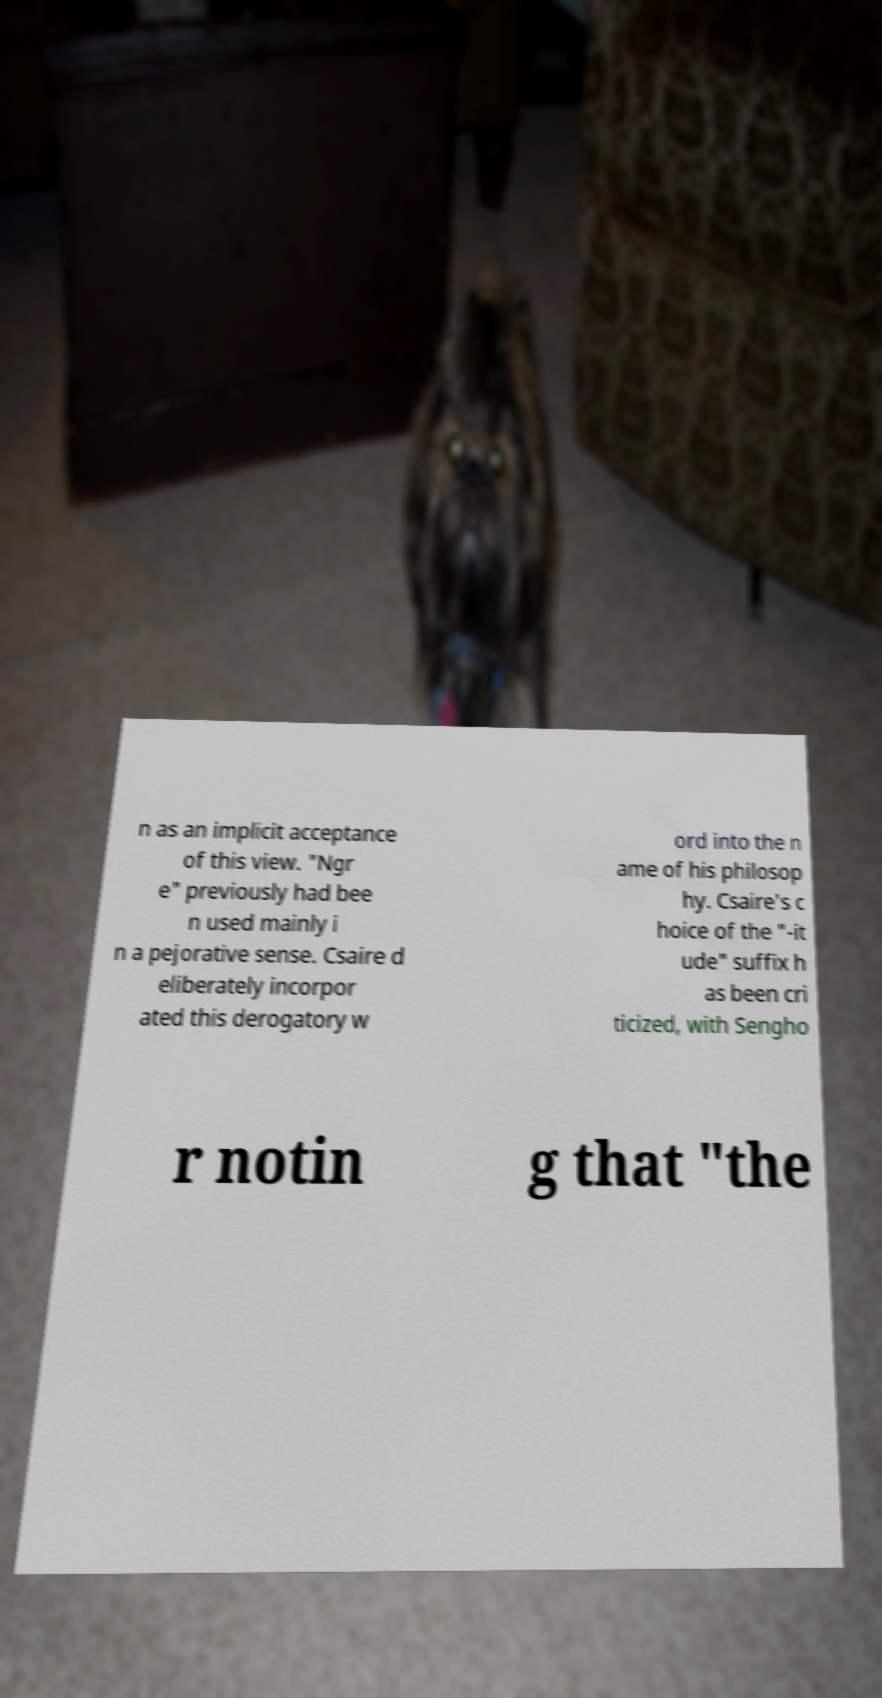I need the written content from this picture converted into text. Can you do that? n as an implicit acceptance of this view. "Ngr e" previously had bee n used mainly i n a pejorative sense. Csaire d eliberately incorpor ated this derogatory w ord into the n ame of his philosop hy. Csaire's c hoice of the "-it ude" suffix h as been cri ticized, with Sengho r notin g that "the 